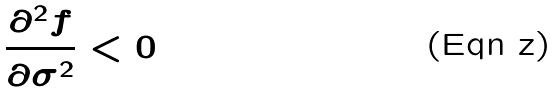<formula> <loc_0><loc_0><loc_500><loc_500>\frac { \partial ^ { 2 } f } { \partial \sigma ^ { 2 } } < 0</formula> 